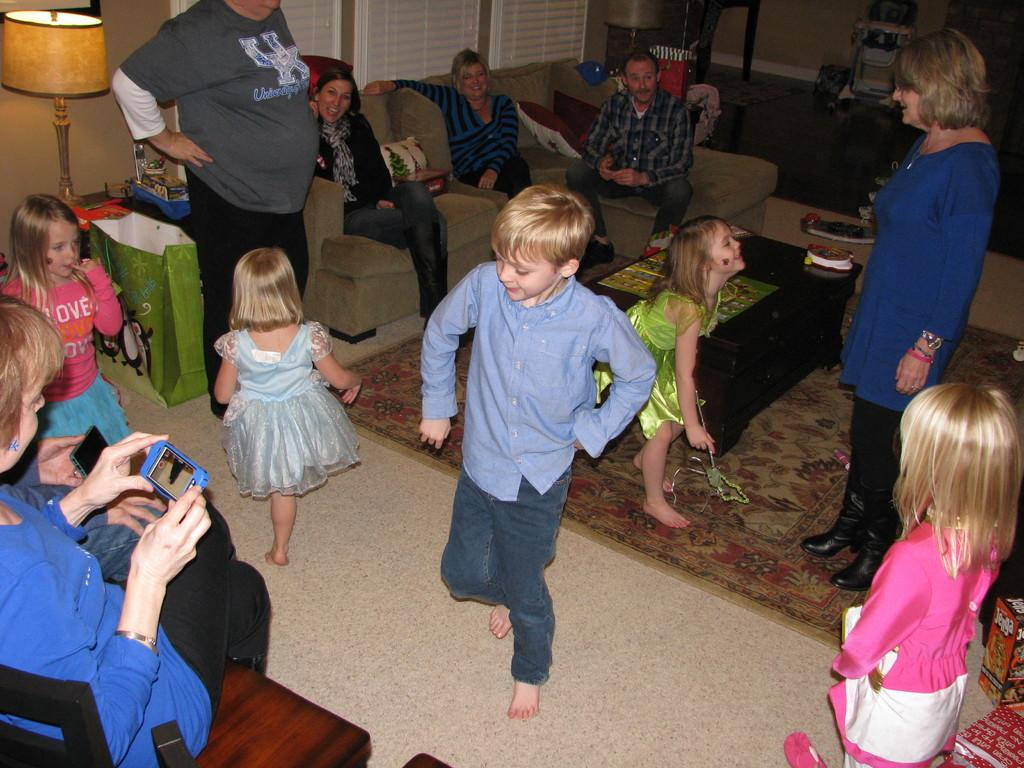What are the kids in the image doing? The kids in the image are dancing. What are the people sitting on in the image? The people are sitting on sofas in the image. What are the people standing doing in the image? There is no specific action mentioned for the people standing in the image. What type of lighting fixture is present in the image? There is a lamp in the image. What is the color of the table in the image? The table in the image is black. How many faces can be seen on the shelf in the image? There is no shelf present in the image, and therefore no faces can be seen on it. 